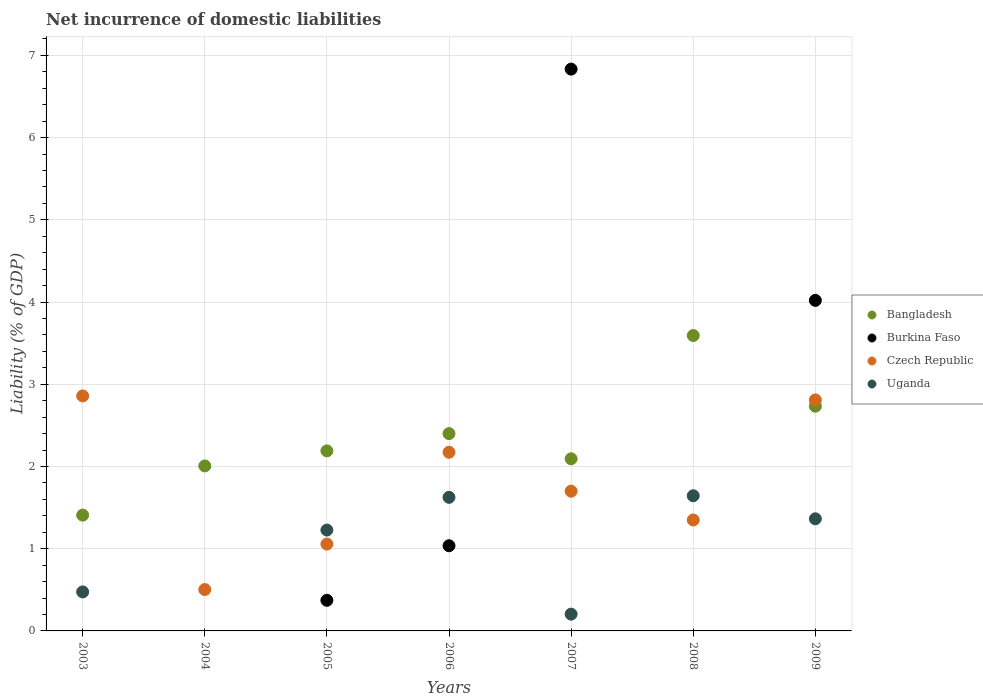How many different coloured dotlines are there?
Offer a very short reply. 4. Is the number of dotlines equal to the number of legend labels?
Keep it short and to the point. No. What is the net incurrence of domestic liabilities in Burkina Faso in 2007?
Keep it short and to the point. 6.83. Across all years, what is the maximum net incurrence of domestic liabilities in Czech Republic?
Offer a terse response. 2.86. Across all years, what is the minimum net incurrence of domestic liabilities in Bangladesh?
Keep it short and to the point. 1.41. In which year was the net incurrence of domestic liabilities in Bangladesh maximum?
Provide a succinct answer. 2008. What is the total net incurrence of domestic liabilities in Bangladesh in the graph?
Your response must be concise. 16.42. What is the difference between the net incurrence of domestic liabilities in Czech Republic in 2003 and that in 2009?
Provide a short and direct response. 0.05. What is the difference between the net incurrence of domestic liabilities in Burkina Faso in 2006 and the net incurrence of domestic liabilities in Czech Republic in 2007?
Ensure brevity in your answer.  -0.66. What is the average net incurrence of domestic liabilities in Uganda per year?
Your response must be concise. 0.93. In the year 2009, what is the difference between the net incurrence of domestic liabilities in Uganda and net incurrence of domestic liabilities in Burkina Faso?
Keep it short and to the point. -2.66. What is the ratio of the net incurrence of domestic liabilities in Czech Republic in 2005 to that in 2006?
Offer a very short reply. 0.49. What is the difference between the highest and the second highest net incurrence of domestic liabilities in Bangladesh?
Offer a very short reply. 0.86. What is the difference between the highest and the lowest net incurrence of domestic liabilities in Uganda?
Make the answer very short. 1.64. In how many years, is the net incurrence of domestic liabilities in Czech Republic greater than the average net incurrence of domestic liabilities in Czech Republic taken over all years?
Ensure brevity in your answer.  3. Is the sum of the net incurrence of domestic liabilities in Bangladesh in 2004 and 2007 greater than the maximum net incurrence of domestic liabilities in Uganda across all years?
Provide a short and direct response. Yes. Does the net incurrence of domestic liabilities in Bangladesh monotonically increase over the years?
Ensure brevity in your answer.  No. Is the net incurrence of domestic liabilities in Burkina Faso strictly greater than the net incurrence of domestic liabilities in Czech Republic over the years?
Offer a terse response. No. Is the net incurrence of domestic liabilities in Bangladesh strictly less than the net incurrence of domestic liabilities in Uganda over the years?
Your answer should be compact. No. What is the difference between two consecutive major ticks on the Y-axis?
Keep it short and to the point. 1. Does the graph contain grids?
Your answer should be compact. Yes. Where does the legend appear in the graph?
Provide a short and direct response. Center right. How many legend labels are there?
Ensure brevity in your answer.  4. How are the legend labels stacked?
Provide a succinct answer. Vertical. What is the title of the graph?
Your answer should be very brief. Net incurrence of domestic liabilities. Does "Virgin Islands" appear as one of the legend labels in the graph?
Make the answer very short. No. What is the label or title of the X-axis?
Provide a short and direct response. Years. What is the label or title of the Y-axis?
Offer a terse response. Liability (% of GDP). What is the Liability (% of GDP) of Bangladesh in 2003?
Offer a terse response. 1.41. What is the Liability (% of GDP) in Burkina Faso in 2003?
Offer a terse response. 0. What is the Liability (% of GDP) in Czech Republic in 2003?
Your answer should be compact. 2.86. What is the Liability (% of GDP) in Uganda in 2003?
Your response must be concise. 0.47. What is the Liability (% of GDP) of Bangladesh in 2004?
Offer a very short reply. 2.01. What is the Liability (% of GDP) in Czech Republic in 2004?
Keep it short and to the point. 0.5. What is the Liability (% of GDP) in Uganda in 2004?
Give a very brief answer. 0. What is the Liability (% of GDP) of Bangladesh in 2005?
Provide a short and direct response. 2.19. What is the Liability (% of GDP) of Burkina Faso in 2005?
Your answer should be compact. 0.37. What is the Liability (% of GDP) in Czech Republic in 2005?
Provide a short and direct response. 1.06. What is the Liability (% of GDP) of Uganda in 2005?
Provide a succinct answer. 1.23. What is the Liability (% of GDP) in Bangladesh in 2006?
Your response must be concise. 2.4. What is the Liability (% of GDP) in Burkina Faso in 2006?
Offer a very short reply. 1.04. What is the Liability (% of GDP) of Czech Republic in 2006?
Make the answer very short. 2.17. What is the Liability (% of GDP) of Uganda in 2006?
Offer a very short reply. 1.62. What is the Liability (% of GDP) of Bangladesh in 2007?
Your response must be concise. 2.09. What is the Liability (% of GDP) in Burkina Faso in 2007?
Offer a terse response. 6.83. What is the Liability (% of GDP) in Czech Republic in 2007?
Provide a succinct answer. 1.7. What is the Liability (% of GDP) of Uganda in 2007?
Ensure brevity in your answer.  0.2. What is the Liability (% of GDP) in Bangladesh in 2008?
Make the answer very short. 3.59. What is the Liability (% of GDP) in Burkina Faso in 2008?
Your answer should be compact. 0. What is the Liability (% of GDP) in Czech Republic in 2008?
Make the answer very short. 1.35. What is the Liability (% of GDP) in Uganda in 2008?
Your response must be concise. 1.64. What is the Liability (% of GDP) of Bangladesh in 2009?
Offer a terse response. 2.73. What is the Liability (% of GDP) of Burkina Faso in 2009?
Keep it short and to the point. 4.02. What is the Liability (% of GDP) of Czech Republic in 2009?
Give a very brief answer. 2.81. What is the Liability (% of GDP) of Uganda in 2009?
Your answer should be compact. 1.36. Across all years, what is the maximum Liability (% of GDP) in Bangladesh?
Your answer should be compact. 3.59. Across all years, what is the maximum Liability (% of GDP) in Burkina Faso?
Offer a terse response. 6.83. Across all years, what is the maximum Liability (% of GDP) of Czech Republic?
Your answer should be very brief. 2.86. Across all years, what is the maximum Liability (% of GDP) in Uganda?
Give a very brief answer. 1.64. Across all years, what is the minimum Liability (% of GDP) of Bangladesh?
Offer a terse response. 1.41. Across all years, what is the minimum Liability (% of GDP) of Burkina Faso?
Provide a succinct answer. 0. Across all years, what is the minimum Liability (% of GDP) of Czech Republic?
Your answer should be compact. 0.5. Across all years, what is the minimum Liability (% of GDP) in Uganda?
Your answer should be very brief. 0. What is the total Liability (% of GDP) in Bangladesh in the graph?
Your answer should be compact. 16.42. What is the total Liability (% of GDP) of Burkina Faso in the graph?
Ensure brevity in your answer.  12.26. What is the total Liability (% of GDP) of Czech Republic in the graph?
Your response must be concise. 12.45. What is the total Liability (% of GDP) in Uganda in the graph?
Your answer should be very brief. 6.54. What is the difference between the Liability (% of GDP) of Bangladesh in 2003 and that in 2004?
Provide a short and direct response. -0.6. What is the difference between the Liability (% of GDP) of Czech Republic in 2003 and that in 2004?
Ensure brevity in your answer.  2.35. What is the difference between the Liability (% of GDP) of Bangladesh in 2003 and that in 2005?
Ensure brevity in your answer.  -0.78. What is the difference between the Liability (% of GDP) of Czech Republic in 2003 and that in 2005?
Your answer should be very brief. 1.8. What is the difference between the Liability (% of GDP) in Uganda in 2003 and that in 2005?
Make the answer very short. -0.75. What is the difference between the Liability (% of GDP) of Bangladesh in 2003 and that in 2006?
Your answer should be compact. -0.99. What is the difference between the Liability (% of GDP) of Czech Republic in 2003 and that in 2006?
Provide a short and direct response. 0.69. What is the difference between the Liability (% of GDP) in Uganda in 2003 and that in 2006?
Offer a terse response. -1.15. What is the difference between the Liability (% of GDP) in Bangladesh in 2003 and that in 2007?
Make the answer very short. -0.69. What is the difference between the Liability (% of GDP) in Czech Republic in 2003 and that in 2007?
Give a very brief answer. 1.16. What is the difference between the Liability (% of GDP) of Uganda in 2003 and that in 2007?
Your answer should be very brief. 0.27. What is the difference between the Liability (% of GDP) in Bangladesh in 2003 and that in 2008?
Offer a terse response. -2.18. What is the difference between the Liability (% of GDP) in Czech Republic in 2003 and that in 2008?
Ensure brevity in your answer.  1.51. What is the difference between the Liability (% of GDP) in Uganda in 2003 and that in 2008?
Keep it short and to the point. -1.17. What is the difference between the Liability (% of GDP) in Bangladesh in 2003 and that in 2009?
Your answer should be very brief. -1.32. What is the difference between the Liability (% of GDP) of Czech Republic in 2003 and that in 2009?
Ensure brevity in your answer.  0.05. What is the difference between the Liability (% of GDP) of Uganda in 2003 and that in 2009?
Give a very brief answer. -0.89. What is the difference between the Liability (% of GDP) of Bangladesh in 2004 and that in 2005?
Offer a very short reply. -0.18. What is the difference between the Liability (% of GDP) of Czech Republic in 2004 and that in 2005?
Your answer should be very brief. -0.55. What is the difference between the Liability (% of GDP) of Bangladesh in 2004 and that in 2006?
Your answer should be compact. -0.39. What is the difference between the Liability (% of GDP) of Czech Republic in 2004 and that in 2006?
Keep it short and to the point. -1.67. What is the difference between the Liability (% of GDP) of Bangladesh in 2004 and that in 2007?
Keep it short and to the point. -0.09. What is the difference between the Liability (% of GDP) in Czech Republic in 2004 and that in 2007?
Your answer should be compact. -1.2. What is the difference between the Liability (% of GDP) in Bangladesh in 2004 and that in 2008?
Make the answer very short. -1.59. What is the difference between the Liability (% of GDP) of Czech Republic in 2004 and that in 2008?
Give a very brief answer. -0.85. What is the difference between the Liability (% of GDP) of Bangladesh in 2004 and that in 2009?
Provide a short and direct response. -0.73. What is the difference between the Liability (% of GDP) of Czech Republic in 2004 and that in 2009?
Your response must be concise. -2.31. What is the difference between the Liability (% of GDP) of Bangladesh in 2005 and that in 2006?
Your answer should be compact. -0.21. What is the difference between the Liability (% of GDP) in Burkina Faso in 2005 and that in 2006?
Your response must be concise. -0.66. What is the difference between the Liability (% of GDP) in Czech Republic in 2005 and that in 2006?
Ensure brevity in your answer.  -1.12. What is the difference between the Liability (% of GDP) in Uganda in 2005 and that in 2006?
Your answer should be compact. -0.4. What is the difference between the Liability (% of GDP) of Bangladesh in 2005 and that in 2007?
Your answer should be very brief. 0.1. What is the difference between the Liability (% of GDP) in Burkina Faso in 2005 and that in 2007?
Your response must be concise. -6.46. What is the difference between the Liability (% of GDP) of Czech Republic in 2005 and that in 2007?
Make the answer very short. -0.64. What is the difference between the Liability (% of GDP) of Uganda in 2005 and that in 2007?
Your answer should be very brief. 1.02. What is the difference between the Liability (% of GDP) in Bangladesh in 2005 and that in 2008?
Provide a short and direct response. -1.4. What is the difference between the Liability (% of GDP) in Czech Republic in 2005 and that in 2008?
Your response must be concise. -0.29. What is the difference between the Liability (% of GDP) of Uganda in 2005 and that in 2008?
Give a very brief answer. -0.42. What is the difference between the Liability (% of GDP) in Bangladesh in 2005 and that in 2009?
Your answer should be compact. -0.54. What is the difference between the Liability (% of GDP) of Burkina Faso in 2005 and that in 2009?
Give a very brief answer. -3.65. What is the difference between the Liability (% of GDP) of Czech Republic in 2005 and that in 2009?
Make the answer very short. -1.75. What is the difference between the Liability (% of GDP) of Uganda in 2005 and that in 2009?
Your response must be concise. -0.14. What is the difference between the Liability (% of GDP) in Bangladesh in 2006 and that in 2007?
Provide a short and direct response. 0.31. What is the difference between the Liability (% of GDP) of Burkina Faso in 2006 and that in 2007?
Offer a very short reply. -5.8. What is the difference between the Liability (% of GDP) of Czech Republic in 2006 and that in 2007?
Your response must be concise. 0.47. What is the difference between the Liability (% of GDP) in Uganda in 2006 and that in 2007?
Your response must be concise. 1.42. What is the difference between the Liability (% of GDP) in Bangladesh in 2006 and that in 2008?
Your response must be concise. -1.19. What is the difference between the Liability (% of GDP) in Czech Republic in 2006 and that in 2008?
Ensure brevity in your answer.  0.82. What is the difference between the Liability (% of GDP) in Uganda in 2006 and that in 2008?
Provide a short and direct response. -0.02. What is the difference between the Liability (% of GDP) of Bangladesh in 2006 and that in 2009?
Provide a short and direct response. -0.33. What is the difference between the Liability (% of GDP) of Burkina Faso in 2006 and that in 2009?
Provide a succinct answer. -2.98. What is the difference between the Liability (% of GDP) in Czech Republic in 2006 and that in 2009?
Your answer should be very brief. -0.64. What is the difference between the Liability (% of GDP) in Uganda in 2006 and that in 2009?
Offer a very short reply. 0.26. What is the difference between the Liability (% of GDP) in Bangladesh in 2007 and that in 2008?
Provide a succinct answer. -1.5. What is the difference between the Liability (% of GDP) in Uganda in 2007 and that in 2008?
Offer a terse response. -1.44. What is the difference between the Liability (% of GDP) of Bangladesh in 2007 and that in 2009?
Offer a very short reply. -0.64. What is the difference between the Liability (% of GDP) in Burkina Faso in 2007 and that in 2009?
Offer a terse response. 2.81. What is the difference between the Liability (% of GDP) of Czech Republic in 2007 and that in 2009?
Your answer should be very brief. -1.11. What is the difference between the Liability (% of GDP) in Uganda in 2007 and that in 2009?
Ensure brevity in your answer.  -1.16. What is the difference between the Liability (% of GDP) of Bangladesh in 2008 and that in 2009?
Offer a very short reply. 0.86. What is the difference between the Liability (% of GDP) of Czech Republic in 2008 and that in 2009?
Your answer should be very brief. -1.46. What is the difference between the Liability (% of GDP) of Uganda in 2008 and that in 2009?
Your response must be concise. 0.28. What is the difference between the Liability (% of GDP) in Bangladesh in 2003 and the Liability (% of GDP) in Czech Republic in 2004?
Ensure brevity in your answer.  0.9. What is the difference between the Liability (% of GDP) in Bangladesh in 2003 and the Liability (% of GDP) in Burkina Faso in 2005?
Make the answer very short. 1.04. What is the difference between the Liability (% of GDP) of Bangladesh in 2003 and the Liability (% of GDP) of Czech Republic in 2005?
Your answer should be very brief. 0.35. What is the difference between the Liability (% of GDP) in Bangladesh in 2003 and the Liability (% of GDP) in Uganda in 2005?
Your response must be concise. 0.18. What is the difference between the Liability (% of GDP) of Czech Republic in 2003 and the Liability (% of GDP) of Uganda in 2005?
Provide a succinct answer. 1.63. What is the difference between the Liability (% of GDP) of Bangladesh in 2003 and the Liability (% of GDP) of Burkina Faso in 2006?
Your answer should be compact. 0.37. What is the difference between the Liability (% of GDP) of Bangladesh in 2003 and the Liability (% of GDP) of Czech Republic in 2006?
Make the answer very short. -0.76. What is the difference between the Liability (% of GDP) of Bangladesh in 2003 and the Liability (% of GDP) of Uganda in 2006?
Your response must be concise. -0.22. What is the difference between the Liability (% of GDP) of Czech Republic in 2003 and the Liability (% of GDP) of Uganda in 2006?
Provide a succinct answer. 1.23. What is the difference between the Liability (% of GDP) of Bangladesh in 2003 and the Liability (% of GDP) of Burkina Faso in 2007?
Your answer should be very brief. -5.42. What is the difference between the Liability (% of GDP) in Bangladesh in 2003 and the Liability (% of GDP) in Czech Republic in 2007?
Make the answer very short. -0.29. What is the difference between the Liability (% of GDP) of Bangladesh in 2003 and the Liability (% of GDP) of Uganda in 2007?
Provide a short and direct response. 1.2. What is the difference between the Liability (% of GDP) of Czech Republic in 2003 and the Liability (% of GDP) of Uganda in 2007?
Offer a terse response. 2.65. What is the difference between the Liability (% of GDP) of Bangladesh in 2003 and the Liability (% of GDP) of Czech Republic in 2008?
Make the answer very short. 0.06. What is the difference between the Liability (% of GDP) in Bangladesh in 2003 and the Liability (% of GDP) in Uganda in 2008?
Offer a very short reply. -0.24. What is the difference between the Liability (% of GDP) in Czech Republic in 2003 and the Liability (% of GDP) in Uganda in 2008?
Provide a succinct answer. 1.21. What is the difference between the Liability (% of GDP) of Bangladesh in 2003 and the Liability (% of GDP) of Burkina Faso in 2009?
Your answer should be compact. -2.61. What is the difference between the Liability (% of GDP) of Bangladesh in 2003 and the Liability (% of GDP) of Czech Republic in 2009?
Your response must be concise. -1.4. What is the difference between the Liability (% of GDP) in Bangladesh in 2003 and the Liability (% of GDP) in Uganda in 2009?
Provide a succinct answer. 0.04. What is the difference between the Liability (% of GDP) in Czech Republic in 2003 and the Liability (% of GDP) in Uganda in 2009?
Ensure brevity in your answer.  1.49. What is the difference between the Liability (% of GDP) in Bangladesh in 2004 and the Liability (% of GDP) in Burkina Faso in 2005?
Offer a very short reply. 1.63. What is the difference between the Liability (% of GDP) in Bangladesh in 2004 and the Liability (% of GDP) in Czech Republic in 2005?
Your answer should be compact. 0.95. What is the difference between the Liability (% of GDP) in Bangladesh in 2004 and the Liability (% of GDP) in Uganda in 2005?
Give a very brief answer. 0.78. What is the difference between the Liability (% of GDP) of Czech Republic in 2004 and the Liability (% of GDP) of Uganda in 2005?
Keep it short and to the point. -0.72. What is the difference between the Liability (% of GDP) of Bangladesh in 2004 and the Liability (% of GDP) of Burkina Faso in 2006?
Make the answer very short. 0.97. What is the difference between the Liability (% of GDP) of Bangladesh in 2004 and the Liability (% of GDP) of Czech Republic in 2006?
Ensure brevity in your answer.  -0.17. What is the difference between the Liability (% of GDP) of Bangladesh in 2004 and the Liability (% of GDP) of Uganda in 2006?
Provide a short and direct response. 0.38. What is the difference between the Liability (% of GDP) in Czech Republic in 2004 and the Liability (% of GDP) in Uganda in 2006?
Provide a short and direct response. -1.12. What is the difference between the Liability (% of GDP) of Bangladesh in 2004 and the Liability (% of GDP) of Burkina Faso in 2007?
Make the answer very short. -4.83. What is the difference between the Liability (% of GDP) of Bangladesh in 2004 and the Liability (% of GDP) of Czech Republic in 2007?
Provide a succinct answer. 0.31. What is the difference between the Liability (% of GDP) in Bangladesh in 2004 and the Liability (% of GDP) in Uganda in 2007?
Ensure brevity in your answer.  1.8. What is the difference between the Liability (% of GDP) in Czech Republic in 2004 and the Liability (% of GDP) in Uganda in 2007?
Your answer should be very brief. 0.3. What is the difference between the Liability (% of GDP) of Bangladesh in 2004 and the Liability (% of GDP) of Czech Republic in 2008?
Your answer should be compact. 0.66. What is the difference between the Liability (% of GDP) in Bangladesh in 2004 and the Liability (% of GDP) in Uganda in 2008?
Your answer should be compact. 0.36. What is the difference between the Liability (% of GDP) of Czech Republic in 2004 and the Liability (% of GDP) of Uganda in 2008?
Offer a terse response. -1.14. What is the difference between the Liability (% of GDP) in Bangladesh in 2004 and the Liability (% of GDP) in Burkina Faso in 2009?
Provide a succinct answer. -2.01. What is the difference between the Liability (% of GDP) in Bangladesh in 2004 and the Liability (% of GDP) in Czech Republic in 2009?
Make the answer very short. -0.8. What is the difference between the Liability (% of GDP) in Bangladesh in 2004 and the Liability (% of GDP) in Uganda in 2009?
Offer a very short reply. 0.64. What is the difference between the Liability (% of GDP) in Czech Republic in 2004 and the Liability (% of GDP) in Uganda in 2009?
Give a very brief answer. -0.86. What is the difference between the Liability (% of GDP) of Bangladesh in 2005 and the Liability (% of GDP) of Burkina Faso in 2006?
Make the answer very short. 1.15. What is the difference between the Liability (% of GDP) of Bangladesh in 2005 and the Liability (% of GDP) of Czech Republic in 2006?
Offer a terse response. 0.02. What is the difference between the Liability (% of GDP) in Bangladesh in 2005 and the Liability (% of GDP) in Uganda in 2006?
Provide a succinct answer. 0.56. What is the difference between the Liability (% of GDP) of Burkina Faso in 2005 and the Liability (% of GDP) of Czech Republic in 2006?
Provide a short and direct response. -1.8. What is the difference between the Liability (% of GDP) of Burkina Faso in 2005 and the Liability (% of GDP) of Uganda in 2006?
Your response must be concise. -1.25. What is the difference between the Liability (% of GDP) in Czech Republic in 2005 and the Liability (% of GDP) in Uganda in 2006?
Give a very brief answer. -0.57. What is the difference between the Liability (% of GDP) of Bangladesh in 2005 and the Liability (% of GDP) of Burkina Faso in 2007?
Your answer should be compact. -4.64. What is the difference between the Liability (% of GDP) in Bangladesh in 2005 and the Liability (% of GDP) in Czech Republic in 2007?
Your answer should be very brief. 0.49. What is the difference between the Liability (% of GDP) of Bangladesh in 2005 and the Liability (% of GDP) of Uganda in 2007?
Your answer should be compact. 1.99. What is the difference between the Liability (% of GDP) in Burkina Faso in 2005 and the Liability (% of GDP) in Czech Republic in 2007?
Your response must be concise. -1.33. What is the difference between the Liability (% of GDP) in Burkina Faso in 2005 and the Liability (% of GDP) in Uganda in 2007?
Your response must be concise. 0.17. What is the difference between the Liability (% of GDP) in Czech Republic in 2005 and the Liability (% of GDP) in Uganda in 2007?
Provide a succinct answer. 0.85. What is the difference between the Liability (% of GDP) in Bangladesh in 2005 and the Liability (% of GDP) in Czech Republic in 2008?
Your answer should be compact. 0.84. What is the difference between the Liability (% of GDP) in Bangladesh in 2005 and the Liability (% of GDP) in Uganda in 2008?
Offer a terse response. 0.55. What is the difference between the Liability (% of GDP) of Burkina Faso in 2005 and the Liability (% of GDP) of Czech Republic in 2008?
Your response must be concise. -0.98. What is the difference between the Liability (% of GDP) in Burkina Faso in 2005 and the Liability (% of GDP) in Uganda in 2008?
Your answer should be compact. -1.27. What is the difference between the Liability (% of GDP) in Czech Republic in 2005 and the Liability (% of GDP) in Uganda in 2008?
Provide a succinct answer. -0.59. What is the difference between the Liability (% of GDP) in Bangladesh in 2005 and the Liability (% of GDP) in Burkina Faso in 2009?
Offer a terse response. -1.83. What is the difference between the Liability (% of GDP) in Bangladesh in 2005 and the Liability (% of GDP) in Czech Republic in 2009?
Offer a terse response. -0.62. What is the difference between the Liability (% of GDP) in Bangladesh in 2005 and the Liability (% of GDP) in Uganda in 2009?
Your response must be concise. 0.83. What is the difference between the Liability (% of GDP) of Burkina Faso in 2005 and the Liability (% of GDP) of Czech Republic in 2009?
Make the answer very short. -2.44. What is the difference between the Liability (% of GDP) of Burkina Faso in 2005 and the Liability (% of GDP) of Uganda in 2009?
Ensure brevity in your answer.  -0.99. What is the difference between the Liability (% of GDP) of Czech Republic in 2005 and the Liability (% of GDP) of Uganda in 2009?
Make the answer very short. -0.31. What is the difference between the Liability (% of GDP) in Bangladesh in 2006 and the Liability (% of GDP) in Burkina Faso in 2007?
Offer a terse response. -4.43. What is the difference between the Liability (% of GDP) in Bangladesh in 2006 and the Liability (% of GDP) in Czech Republic in 2007?
Offer a terse response. 0.7. What is the difference between the Liability (% of GDP) in Bangladesh in 2006 and the Liability (% of GDP) in Uganda in 2007?
Offer a very short reply. 2.2. What is the difference between the Liability (% of GDP) in Burkina Faso in 2006 and the Liability (% of GDP) in Czech Republic in 2007?
Provide a short and direct response. -0.66. What is the difference between the Liability (% of GDP) in Burkina Faso in 2006 and the Liability (% of GDP) in Uganda in 2007?
Keep it short and to the point. 0.83. What is the difference between the Liability (% of GDP) of Czech Republic in 2006 and the Liability (% of GDP) of Uganda in 2007?
Your response must be concise. 1.97. What is the difference between the Liability (% of GDP) in Bangladesh in 2006 and the Liability (% of GDP) in Czech Republic in 2008?
Offer a very short reply. 1.05. What is the difference between the Liability (% of GDP) in Bangladesh in 2006 and the Liability (% of GDP) in Uganda in 2008?
Your response must be concise. 0.76. What is the difference between the Liability (% of GDP) in Burkina Faso in 2006 and the Liability (% of GDP) in Czech Republic in 2008?
Provide a short and direct response. -0.31. What is the difference between the Liability (% of GDP) of Burkina Faso in 2006 and the Liability (% of GDP) of Uganda in 2008?
Your answer should be compact. -0.61. What is the difference between the Liability (% of GDP) in Czech Republic in 2006 and the Liability (% of GDP) in Uganda in 2008?
Offer a very short reply. 0.53. What is the difference between the Liability (% of GDP) in Bangladesh in 2006 and the Liability (% of GDP) in Burkina Faso in 2009?
Give a very brief answer. -1.62. What is the difference between the Liability (% of GDP) in Bangladesh in 2006 and the Liability (% of GDP) in Czech Republic in 2009?
Your answer should be very brief. -0.41. What is the difference between the Liability (% of GDP) in Bangladesh in 2006 and the Liability (% of GDP) in Uganda in 2009?
Your answer should be compact. 1.04. What is the difference between the Liability (% of GDP) in Burkina Faso in 2006 and the Liability (% of GDP) in Czech Republic in 2009?
Provide a short and direct response. -1.77. What is the difference between the Liability (% of GDP) of Burkina Faso in 2006 and the Liability (% of GDP) of Uganda in 2009?
Your response must be concise. -0.33. What is the difference between the Liability (% of GDP) of Czech Republic in 2006 and the Liability (% of GDP) of Uganda in 2009?
Keep it short and to the point. 0.81. What is the difference between the Liability (% of GDP) in Bangladesh in 2007 and the Liability (% of GDP) in Czech Republic in 2008?
Give a very brief answer. 0.74. What is the difference between the Liability (% of GDP) of Bangladesh in 2007 and the Liability (% of GDP) of Uganda in 2008?
Keep it short and to the point. 0.45. What is the difference between the Liability (% of GDP) of Burkina Faso in 2007 and the Liability (% of GDP) of Czech Republic in 2008?
Keep it short and to the point. 5.48. What is the difference between the Liability (% of GDP) of Burkina Faso in 2007 and the Liability (% of GDP) of Uganda in 2008?
Provide a succinct answer. 5.19. What is the difference between the Liability (% of GDP) of Czech Republic in 2007 and the Liability (% of GDP) of Uganda in 2008?
Make the answer very short. 0.06. What is the difference between the Liability (% of GDP) in Bangladesh in 2007 and the Liability (% of GDP) in Burkina Faso in 2009?
Offer a terse response. -1.93. What is the difference between the Liability (% of GDP) in Bangladesh in 2007 and the Liability (% of GDP) in Czech Republic in 2009?
Ensure brevity in your answer.  -0.72. What is the difference between the Liability (% of GDP) of Bangladesh in 2007 and the Liability (% of GDP) of Uganda in 2009?
Provide a short and direct response. 0.73. What is the difference between the Liability (% of GDP) of Burkina Faso in 2007 and the Liability (% of GDP) of Czech Republic in 2009?
Provide a short and direct response. 4.02. What is the difference between the Liability (% of GDP) of Burkina Faso in 2007 and the Liability (% of GDP) of Uganda in 2009?
Offer a terse response. 5.47. What is the difference between the Liability (% of GDP) of Czech Republic in 2007 and the Liability (% of GDP) of Uganda in 2009?
Provide a short and direct response. 0.34. What is the difference between the Liability (% of GDP) in Bangladesh in 2008 and the Liability (% of GDP) in Burkina Faso in 2009?
Your answer should be very brief. -0.43. What is the difference between the Liability (% of GDP) in Bangladesh in 2008 and the Liability (% of GDP) in Czech Republic in 2009?
Make the answer very short. 0.78. What is the difference between the Liability (% of GDP) of Bangladesh in 2008 and the Liability (% of GDP) of Uganda in 2009?
Provide a short and direct response. 2.23. What is the difference between the Liability (% of GDP) of Czech Republic in 2008 and the Liability (% of GDP) of Uganda in 2009?
Your answer should be very brief. -0.01. What is the average Liability (% of GDP) of Bangladesh per year?
Ensure brevity in your answer.  2.35. What is the average Liability (% of GDP) in Burkina Faso per year?
Give a very brief answer. 1.75. What is the average Liability (% of GDP) of Czech Republic per year?
Provide a succinct answer. 1.78. What is the average Liability (% of GDP) of Uganda per year?
Your response must be concise. 0.93. In the year 2003, what is the difference between the Liability (% of GDP) in Bangladesh and Liability (% of GDP) in Czech Republic?
Provide a short and direct response. -1.45. In the year 2003, what is the difference between the Liability (% of GDP) of Bangladesh and Liability (% of GDP) of Uganda?
Your answer should be compact. 0.93. In the year 2003, what is the difference between the Liability (% of GDP) in Czech Republic and Liability (% of GDP) in Uganda?
Provide a succinct answer. 2.38. In the year 2004, what is the difference between the Liability (% of GDP) of Bangladesh and Liability (% of GDP) of Czech Republic?
Your response must be concise. 1.5. In the year 2005, what is the difference between the Liability (% of GDP) of Bangladesh and Liability (% of GDP) of Burkina Faso?
Provide a short and direct response. 1.82. In the year 2005, what is the difference between the Liability (% of GDP) in Bangladesh and Liability (% of GDP) in Czech Republic?
Offer a terse response. 1.13. In the year 2005, what is the difference between the Liability (% of GDP) of Bangladesh and Liability (% of GDP) of Uganda?
Provide a short and direct response. 0.96. In the year 2005, what is the difference between the Liability (% of GDP) in Burkina Faso and Liability (% of GDP) in Czech Republic?
Provide a short and direct response. -0.68. In the year 2005, what is the difference between the Liability (% of GDP) in Burkina Faso and Liability (% of GDP) in Uganda?
Your answer should be very brief. -0.85. In the year 2005, what is the difference between the Liability (% of GDP) of Czech Republic and Liability (% of GDP) of Uganda?
Your answer should be very brief. -0.17. In the year 2006, what is the difference between the Liability (% of GDP) of Bangladesh and Liability (% of GDP) of Burkina Faso?
Provide a short and direct response. 1.36. In the year 2006, what is the difference between the Liability (% of GDP) of Bangladesh and Liability (% of GDP) of Czech Republic?
Ensure brevity in your answer.  0.23. In the year 2006, what is the difference between the Liability (% of GDP) in Bangladesh and Liability (% of GDP) in Uganda?
Make the answer very short. 0.78. In the year 2006, what is the difference between the Liability (% of GDP) of Burkina Faso and Liability (% of GDP) of Czech Republic?
Your answer should be very brief. -1.14. In the year 2006, what is the difference between the Liability (% of GDP) of Burkina Faso and Liability (% of GDP) of Uganda?
Your answer should be compact. -0.59. In the year 2006, what is the difference between the Liability (% of GDP) in Czech Republic and Liability (% of GDP) in Uganda?
Make the answer very short. 0.55. In the year 2007, what is the difference between the Liability (% of GDP) of Bangladesh and Liability (% of GDP) of Burkina Faso?
Offer a very short reply. -4.74. In the year 2007, what is the difference between the Liability (% of GDP) of Bangladesh and Liability (% of GDP) of Czech Republic?
Give a very brief answer. 0.39. In the year 2007, what is the difference between the Liability (% of GDP) in Bangladesh and Liability (% of GDP) in Uganda?
Keep it short and to the point. 1.89. In the year 2007, what is the difference between the Liability (% of GDP) in Burkina Faso and Liability (% of GDP) in Czech Republic?
Your answer should be compact. 5.13. In the year 2007, what is the difference between the Liability (% of GDP) of Burkina Faso and Liability (% of GDP) of Uganda?
Your response must be concise. 6.63. In the year 2007, what is the difference between the Liability (% of GDP) of Czech Republic and Liability (% of GDP) of Uganda?
Provide a succinct answer. 1.5. In the year 2008, what is the difference between the Liability (% of GDP) in Bangladesh and Liability (% of GDP) in Czech Republic?
Your answer should be very brief. 2.24. In the year 2008, what is the difference between the Liability (% of GDP) of Bangladesh and Liability (% of GDP) of Uganda?
Your answer should be compact. 1.95. In the year 2008, what is the difference between the Liability (% of GDP) in Czech Republic and Liability (% of GDP) in Uganda?
Your answer should be compact. -0.29. In the year 2009, what is the difference between the Liability (% of GDP) of Bangladesh and Liability (% of GDP) of Burkina Faso?
Your answer should be compact. -1.29. In the year 2009, what is the difference between the Liability (% of GDP) in Bangladesh and Liability (% of GDP) in Czech Republic?
Keep it short and to the point. -0.08. In the year 2009, what is the difference between the Liability (% of GDP) of Bangladesh and Liability (% of GDP) of Uganda?
Ensure brevity in your answer.  1.37. In the year 2009, what is the difference between the Liability (% of GDP) in Burkina Faso and Liability (% of GDP) in Czech Republic?
Offer a very short reply. 1.21. In the year 2009, what is the difference between the Liability (% of GDP) in Burkina Faso and Liability (% of GDP) in Uganda?
Your answer should be compact. 2.66. In the year 2009, what is the difference between the Liability (% of GDP) in Czech Republic and Liability (% of GDP) in Uganda?
Provide a succinct answer. 1.45. What is the ratio of the Liability (% of GDP) in Bangladesh in 2003 to that in 2004?
Your answer should be compact. 0.7. What is the ratio of the Liability (% of GDP) in Czech Republic in 2003 to that in 2004?
Your response must be concise. 5.68. What is the ratio of the Liability (% of GDP) of Bangladesh in 2003 to that in 2005?
Ensure brevity in your answer.  0.64. What is the ratio of the Liability (% of GDP) of Czech Republic in 2003 to that in 2005?
Your answer should be compact. 2.71. What is the ratio of the Liability (% of GDP) in Uganda in 2003 to that in 2005?
Offer a very short reply. 0.39. What is the ratio of the Liability (% of GDP) in Bangladesh in 2003 to that in 2006?
Your answer should be very brief. 0.59. What is the ratio of the Liability (% of GDP) of Czech Republic in 2003 to that in 2006?
Your answer should be compact. 1.32. What is the ratio of the Liability (% of GDP) of Uganda in 2003 to that in 2006?
Make the answer very short. 0.29. What is the ratio of the Liability (% of GDP) of Bangladesh in 2003 to that in 2007?
Offer a very short reply. 0.67. What is the ratio of the Liability (% of GDP) in Czech Republic in 2003 to that in 2007?
Provide a succinct answer. 1.68. What is the ratio of the Liability (% of GDP) in Uganda in 2003 to that in 2007?
Make the answer very short. 2.33. What is the ratio of the Liability (% of GDP) in Bangladesh in 2003 to that in 2008?
Give a very brief answer. 0.39. What is the ratio of the Liability (% of GDP) in Czech Republic in 2003 to that in 2008?
Offer a terse response. 2.12. What is the ratio of the Liability (% of GDP) of Uganda in 2003 to that in 2008?
Keep it short and to the point. 0.29. What is the ratio of the Liability (% of GDP) in Bangladesh in 2003 to that in 2009?
Offer a very short reply. 0.52. What is the ratio of the Liability (% of GDP) of Czech Republic in 2003 to that in 2009?
Make the answer very short. 1.02. What is the ratio of the Liability (% of GDP) of Uganda in 2003 to that in 2009?
Make the answer very short. 0.35. What is the ratio of the Liability (% of GDP) of Bangladesh in 2004 to that in 2005?
Make the answer very short. 0.92. What is the ratio of the Liability (% of GDP) of Czech Republic in 2004 to that in 2005?
Your response must be concise. 0.48. What is the ratio of the Liability (% of GDP) in Bangladesh in 2004 to that in 2006?
Ensure brevity in your answer.  0.84. What is the ratio of the Liability (% of GDP) in Czech Republic in 2004 to that in 2006?
Ensure brevity in your answer.  0.23. What is the ratio of the Liability (% of GDP) in Bangladesh in 2004 to that in 2007?
Offer a very short reply. 0.96. What is the ratio of the Liability (% of GDP) in Czech Republic in 2004 to that in 2007?
Ensure brevity in your answer.  0.3. What is the ratio of the Liability (% of GDP) of Bangladesh in 2004 to that in 2008?
Ensure brevity in your answer.  0.56. What is the ratio of the Liability (% of GDP) of Czech Republic in 2004 to that in 2008?
Provide a succinct answer. 0.37. What is the ratio of the Liability (% of GDP) of Bangladesh in 2004 to that in 2009?
Offer a terse response. 0.73. What is the ratio of the Liability (% of GDP) in Czech Republic in 2004 to that in 2009?
Your response must be concise. 0.18. What is the ratio of the Liability (% of GDP) in Bangladesh in 2005 to that in 2006?
Provide a succinct answer. 0.91. What is the ratio of the Liability (% of GDP) in Burkina Faso in 2005 to that in 2006?
Provide a succinct answer. 0.36. What is the ratio of the Liability (% of GDP) in Czech Republic in 2005 to that in 2006?
Your answer should be very brief. 0.49. What is the ratio of the Liability (% of GDP) in Uganda in 2005 to that in 2006?
Offer a very short reply. 0.76. What is the ratio of the Liability (% of GDP) in Bangladesh in 2005 to that in 2007?
Your answer should be compact. 1.05. What is the ratio of the Liability (% of GDP) of Burkina Faso in 2005 to that in 2007?
Provide a succinct answer. 0.05. What is the ratio of the Liability (% of GDP) in Czech Republic in 2005 to that in 2007?
Offer a terse response. 0.62. What is the ratio of the Liability (% of GDP) in Uganda in 2005 to that in 2007?
Your answer should be compact. 6.01. What is the ratio of the Liability (% of GDP) of Bangladesh in 2005 to that in 2008?
Provide a succinct answer. 0.61. What is the ratio of the Liability (% of GDP) in Czech Republic in 2005 to that in 2008?
Offer a terse response. 0.78. What is the ratio of the Liability (% of GDP) of Uganda in 2005 to that in 2008?
Ensure brevity in your answer.  0.75. What is the ratio of the Liability (% of GDP) in Bangladesh in 2005 to that in 2009?
Offer a terse response. 0.8. What is the ratio of the Liability (% of GDP) of Burkina Faso in 2005 to that in 2009?
Provide a succinct answer. 0.09. What is the ratio of the Liability (% of GDP) in Czech Republic in 2005 to that in 2009?
Provide a succinct answer. 0.38. What is the ratio of the Liability (% of GDP) in Uganda in 2005 to that in 2009?
Keep it short and to the point. 0.9. What is the ratio of the Liability (% of GDP) in Bangladesh in 2006 to that in 2007?
Offer a very short reply. 1.15. What is the ratio of the Liability (% of GDP) in Burkina Faso in 2006 to that in 2007?
Your answer should be compact. 0.15. What is the ratio of the Liability (% of GDP) in Czech Republic in 2006 to that in 2007?
Offer a very short reply. 1.28. What is the ratio of the Liability (% of GDP) in Uganda in 2006 to that in 2007?
Ensure brevity in your answer.  7.96. What is the ratio of the Liability (% of GDP) in Bangladesh in 2006 to that in 2008?
Your answer should be very brief. 0.67. What is the ratio of the Liability (% of GDP) of Czech Republic in 2006 to that in 2008?
Your answer should be very brief. 1.61. What is the ratio of the Liability (% of GDP) in Bangladesh in 2006 to that in 2009?
Provide a succinct answer. 0.88. What is the ratio of the Liability (% of GDP) of Burkina Faso in 2006 to that in 2009?
Give a very brief answer. 0.26. What is the ratio of the Liability (% of GDP) in Czech Republic in 2006 to that in 2009?
Keep it short and to the point. 0.77. What is the ratio of the Liability (% of GDP) of Uganda in 2006 to that in 2009?
Make the answer very short. 1.19. What is the ratio of the Liability (% of GDP) of Bangladesh in 2007 to that in 2008?
Provide a succinct answer. 0.58. What is the ratio of the Liability (% of GDP) in Czech Republic in 2007 to that in 2008?
Provide a succinct answer. 1.26. What is the ratio of the Liability (% of GDP) of Uganda in 2007 to that in 2008?
Your answer should be very brief. 0.12. What is the ratio of the Liability (% of GDP) in Bangladesh in 2007 to that in 2009?
Give a very brief answer. 0.77. What is the ratio of the Liability (% of GDP) in Burkina Faso in 2007 to that in 2009?
Provide a short and direct response. 1.7. What is the ratio of the Liability (% of GDP) of Czech Republic in 2007 to that in 2009?
Make the answer very short. 0.6. What is the ratio of the Liability (% of GDP) in Uganda in 2007 to that in 2009?
Your answer should be very brief. 0.15. What is the ratio of the Liability (% of GDP) in Bangladesh in 2008 to that in 2009?
Provide a short and direct response. 1.31. What is the ratio of the Liability (% of GDP) of Czech Republic in 2008 to that in 2009?
Your response must be concise. 0.48. What is the ratio of the Liability (% of GDP) in Uganda in 2008 to that in 2009?
Ensure brevity in your answer.  1.21. What is the difference between the highest and the second highest Liability (% of GDP) in Bangladesh?
Offer a very short reply. 0.86. What is the difference between the highest and the second highest Liability (% of GDP) of Burkina Faso?
Provide a succinct answer. 2.81. What is the difference between the highest and the second highest Liability (% of GDP) of Czech Republic?
Make the answer very short. 0.05. What is the difference between the highest and the second highest Liability (% of GDP) of Uganda?
Your response must be concise. 0.02. What is the difference between the highest and the lowest Liability (% of GDP) of Bangladesh?
Provide a short and direct response. 2.18. What is the difference between the highest and the lowest Liability (% of GDP) of Burkina Faso?
Keep it short and to the point. 6.83. What is the difference between the highest and the lowest Liability (% of GDP) of Czech Republic?
Provide a succinct answer. 2.35. What is the difference between the highest and the lowest Liability (% of GDP) in Uganda?
Your answer should be very brief. 1.64. 